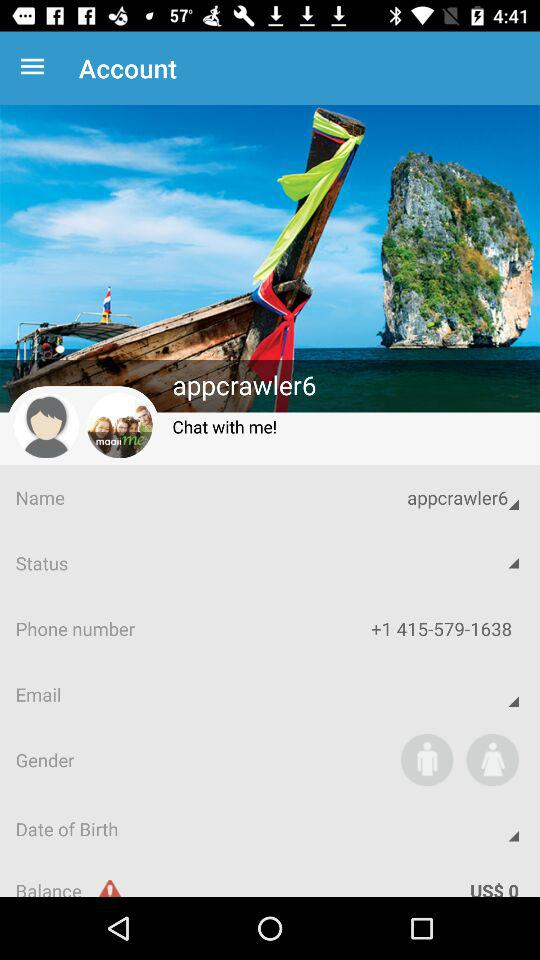What is the balance? The balance is 0 USD. 